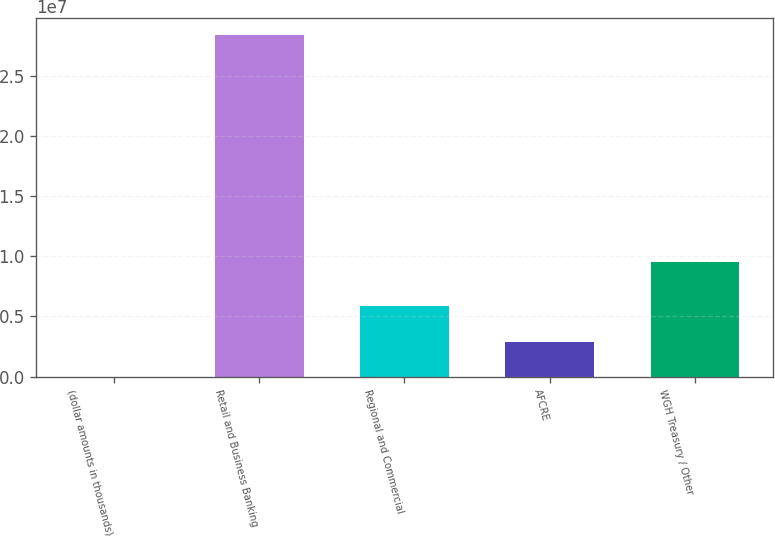<chart> <loc_0><loc_0><loc_500><loc_500><bar_chart><fcel>(dollar amounts in thousands)<fcel>Retail and Business Banking<fcel>Regional and Commercial<fcel>AFCRE<fcel>WGH Treasury / Other<nl><fcel>2012<fcel>2.83673e+07<fcel>5.86286e+06<fcel>2.83854e+06<fcel>9.50778e+06<nl></chart> 